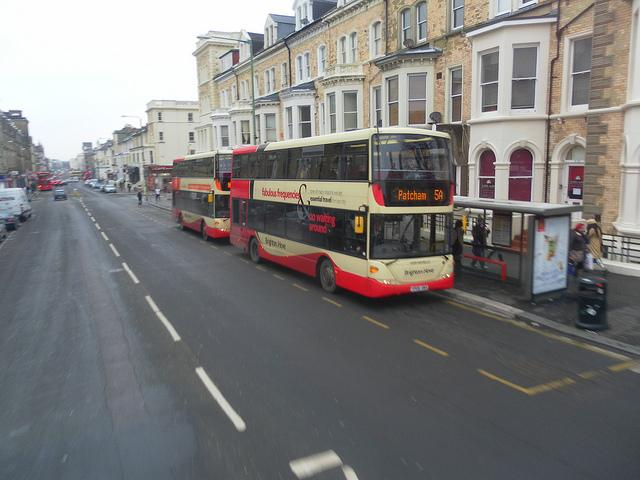When was the double-decker bus invented? 1847 